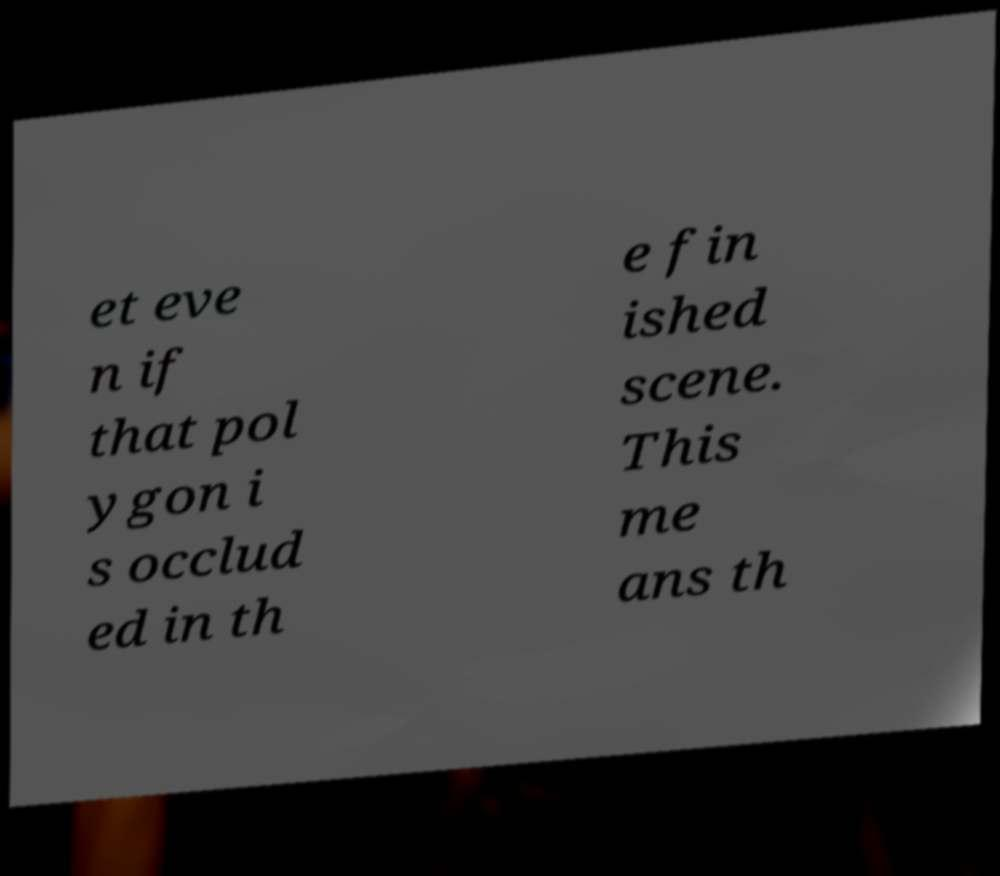Please identify and transcribe the text found in this image. et eve n if that pol ygon i s occlud ed in th e fin ished scene. This me ans th 